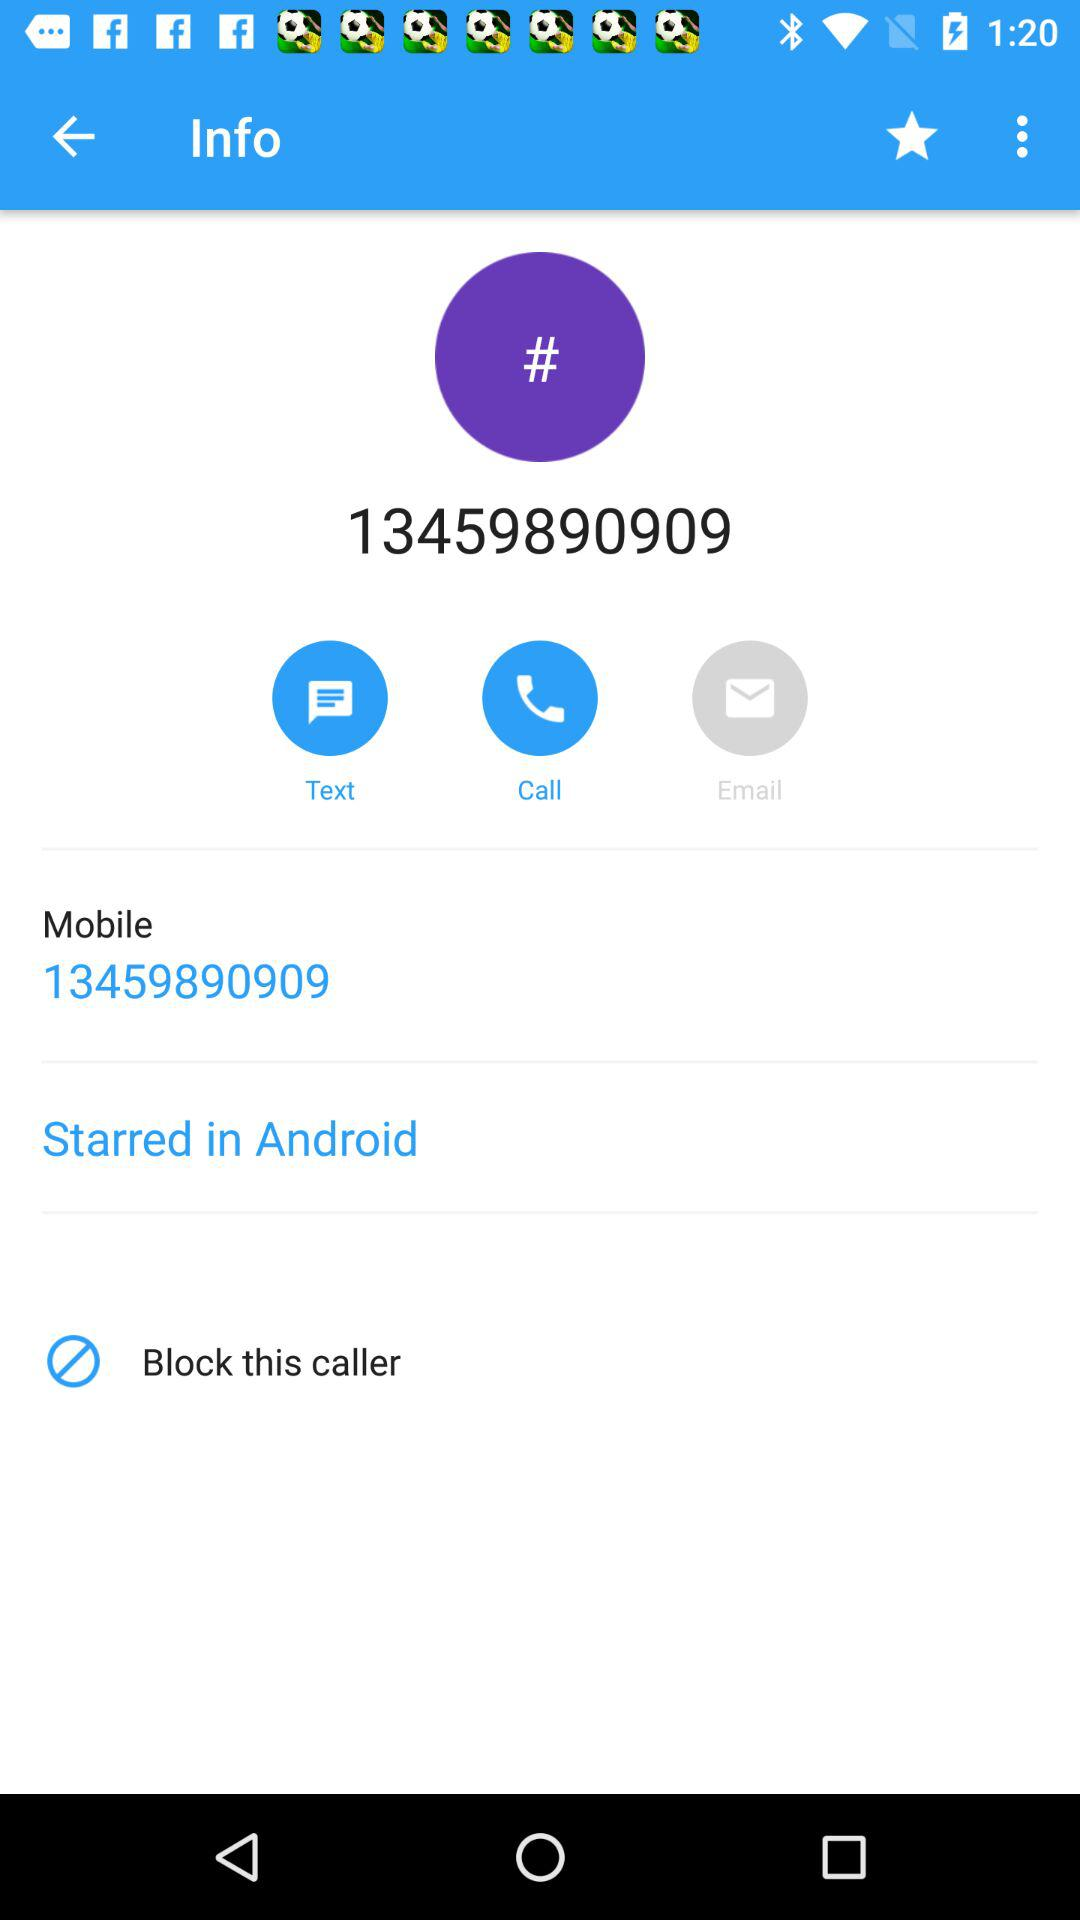What is the mobile number? The mobile number is 13459890909. 